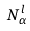<formula> <loc_0><loc_0><loc_500><loc_500>N _ { \alpha } ^ { l }</formula> 